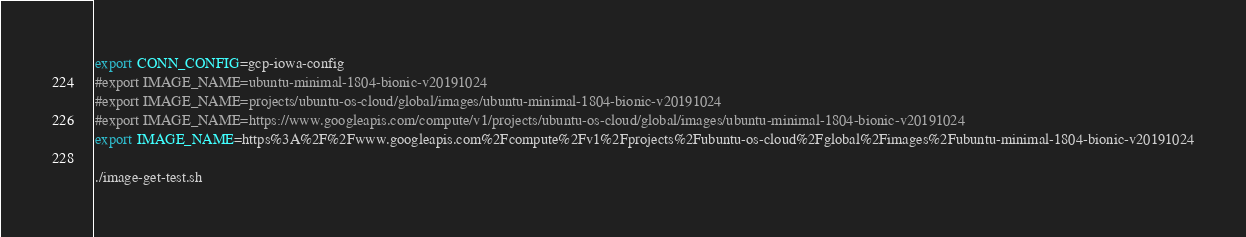Convert code to text. <code><loc_0><loc_0><loc_500><loc_500><_Bash_>export CONN_CONFIG=gcp-iowa-config
#export IMAGE_NAME=ubuntu-minimal-1804-bionic-v20191024
#export IMAGE_NAME=projects/ubuntu-os-cloud/global/images/ubuntu-minimal-1804-bionic-v20191024
#export IMAGE_NAME=https://www.googleapis.com/compute/v1/projects/ubuntu-os-cloud/global/images/ubuntu-minimal-1804-bionic-v20191024
export IMAGE_NAME=https%3A%2F%2Fwww.googleapis.com%2Fcompute%2Fv1%2Fprojects%2Fubuntu-os-cloud%2Fglobal%2Fimages%2Fubuntu-minimal-1804-bionic-v20191024

./image-get-test.sh
</code> 